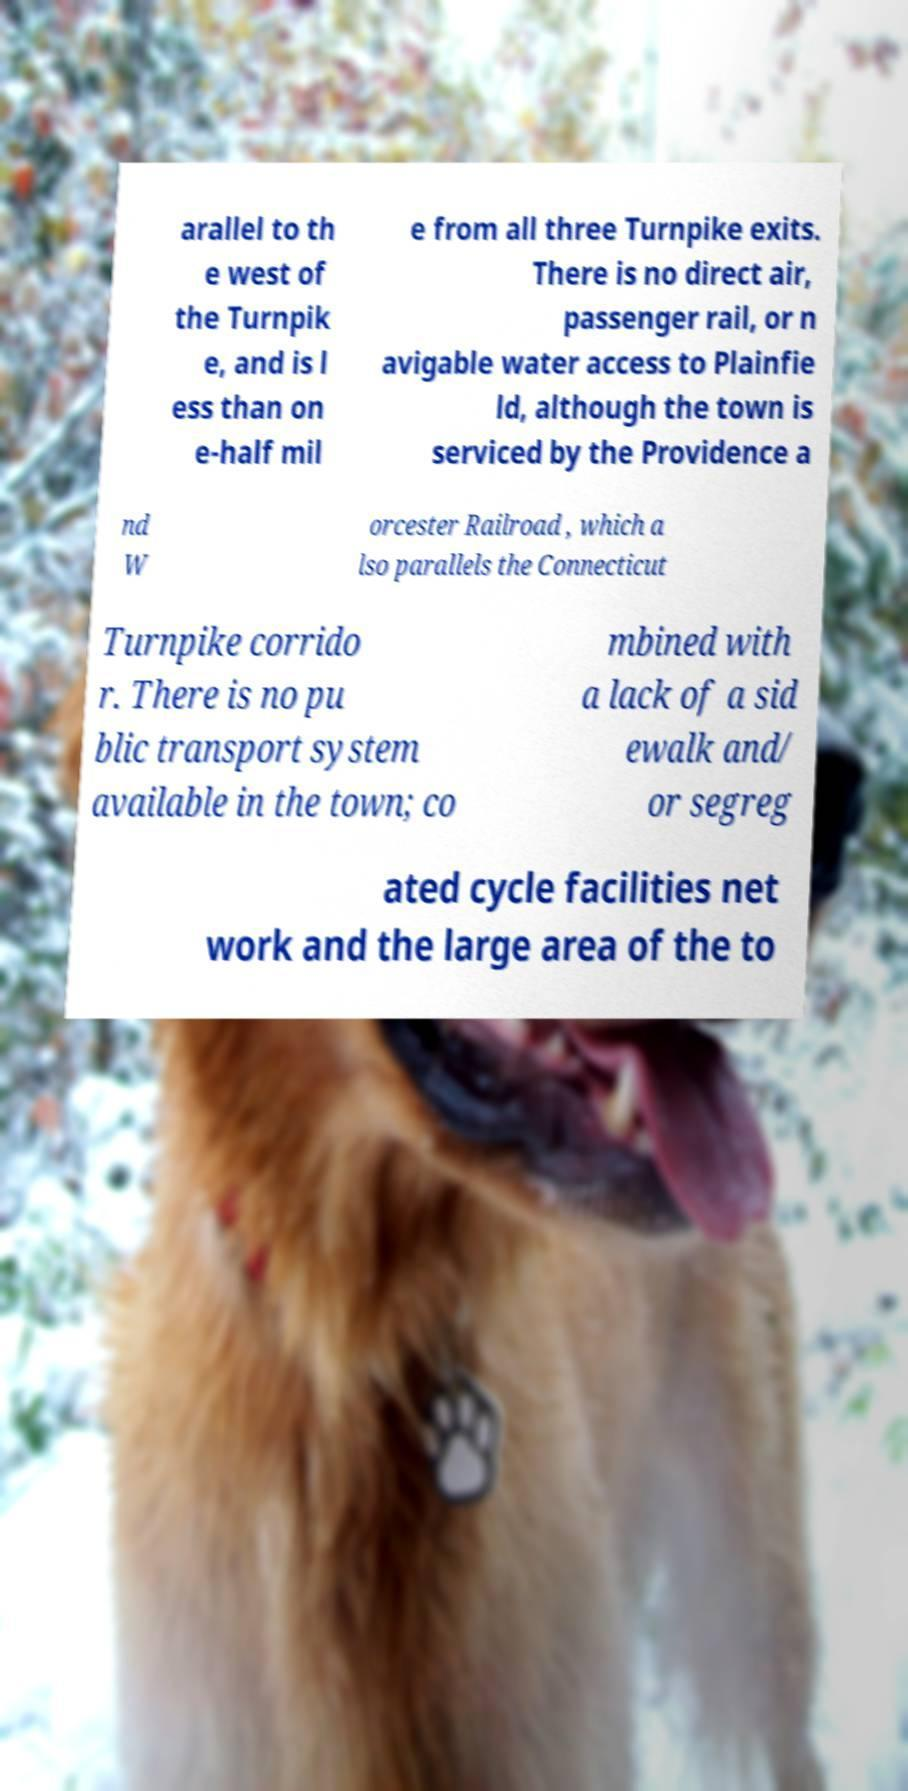Please identify and transcribe the text found in this image. arallel to th e west of the Turnpik e, and is l ess than on e-half mil e from all three Turnpike exits. There is no direct air, passenger rail, or n avigable water access to Plainfie ld, although the town is serviced by the Providence a nd W orcester Railroad , which a lso parallels the Connecticut Turnpike corrido r. There is no pu blic transport system available in the town; co mbined with a lack of a sid ewalk and/ or segreg ated cycle facilities net work and the large area of the to 